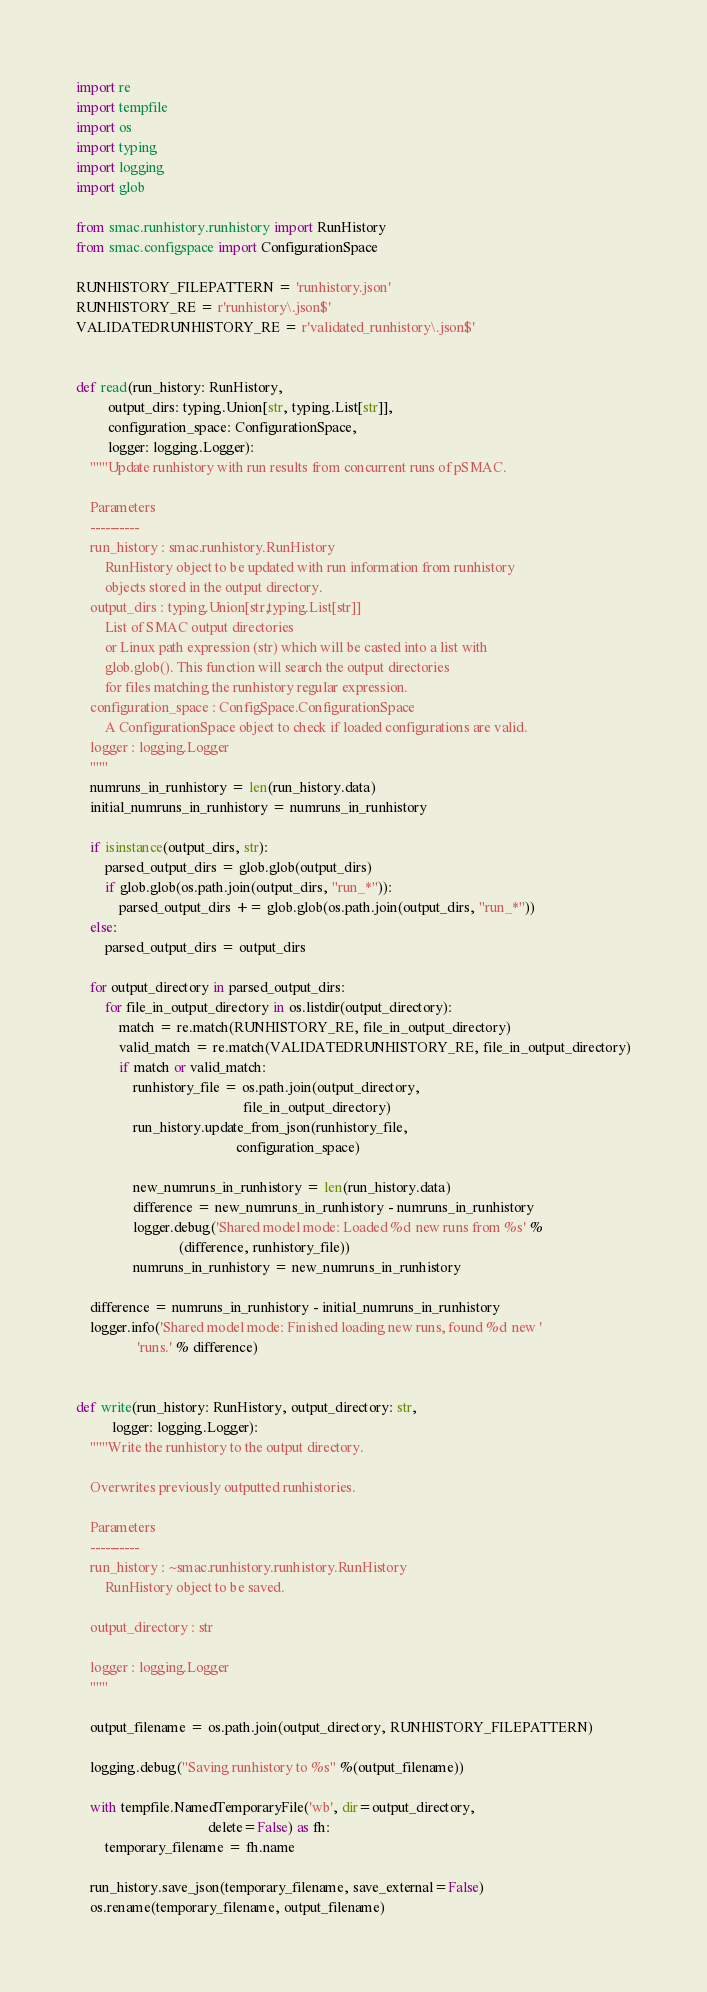Convert code to text. <code><loc_0><loc_0><loc_500><loc_500><_Python_>import re
import tempfile
import os
import typing
import logging
import glob

from smac.runhistory.runhistory import RunHistory
from smac.configspace import ConfigurationSpace

RUNHISTORY_FILEPATTERN = 'runhistory.json'
RUNHISTORY_RE = r'runhistory\.json$'
VALIDATEDRUNHISTORY_RE = r'validated_runhistory\.json$'


def read(run_history: RunHistory,
         output_dirs: typing.Union[str, typing.List[str]],
         configuration_space: ConfigurationSpace,
         logger: logging.Logger):
    """Update runhistory with run results from concurrent runs of pSMAC.

    Parameters
    ----------
    run_history : smac.runhistory.RunHistory
        RunHistory object to be updated with run information from runhistory
        objects stored in the output directory.
    output_dirs : typing.Union[str,typing.List[str]]
        List of SMAC output directories
        or Linux path expression (str) which will be casted into a list with
        glob.glob(). This function will search the output directories
        for files matching the runhistory regular expression.
    configuration_space : ConfigSpace.ConfigurationSpace
        A ConfigurationSpace object to check if loaded configurations are valid.
    logger : logging.Logger
    """
    numruns_in_runhistory = len(run_history.data)
    initial_numruns_in_runhistory = numruns_in_runhistory

    if isinstance(output_dirs, str):
        parsed_output_dirs = glob.glob(output_dirs)
        if glob.glob(os.path.join(output_dirs, "run_*")):
            parsed_output_dirs += glob.glob(os.path.join(output_dirs, "run_*"))
    else:
        parsed_output_dirs = output_dirs

    for output_directory in parsed_output_dirs:
        for file_in_output_directory in os.listdir(output_directory):
            match = re.match(RUNHISTORY_RE, file_in_output_directory)
            valid_match = re.match(VALIDATEDRUNHISTORY_RE, file_in_output_directory)
            if match or valid_match:
                runhistory_file = os.path.join(output_directory,
                                               file_in_output_directory)
                run_history.update_from_json(runhistory_file,
                                             configuration_space)

                new_numruns_in_runhistory = len(run_history.data)
                difference = new_numruns_in_runhistory - numruns_in_runhistory
                logger.debug('Shared model mode: Loaded %d new runs from %s' %
                             (difference, runhistory_file))
                numruns_in_runhistory = new_numruns_in_runhistory

    difference = numruns_in_runhistory - initial_numruns_in_runhistory
    logger.info('Shared model mode: Finished loading new runs, found %d new '
                 'runs.' % difference)


def write(run_history: RunHistory, output_directory: str,
          logger: logging.Logger):
    """Write the runhistory to the output directory.

    Overwrites previously outputted runhistories.

    Parameters
    ----------
    run_history : ~smac.runhistory.runhistory.RunHistory
        RunHistory object to be saved.

    output_directory : str

    logger : logging.Logger
    """

    output_filename = os.path.join(output_directory, RUNHISTORY_FILEPATTERN)

    logging.debug("Saving runhistory to %s" %(output_filename))

    with tempfile.NamedTemporaryFile('wb', dir=output_directory,
                                     delete=False) as fh:
        temporary_filename = fh.name

    run_history.save_json(temporary_filename, save_external=False)
    os.rename(temporary_filename, output_filename)
</code> 